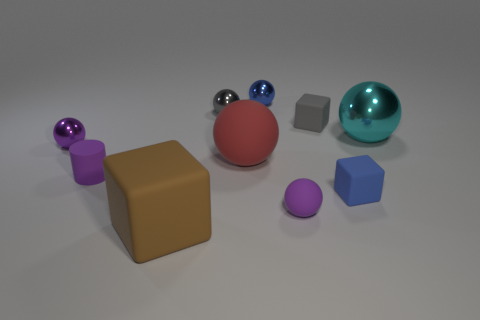Can you tell me about the lighting of this scene? The lighting of the scene is soft and diffused, coming from above as indicated by the soft shadows beneath the objects. The lack of harsh shadows suggests an indirect light source, creating a calm and evenly lit environment that minimizes contrast and allows the true colors of the objects to be visible.  How does the surface texture affect the perception of these objects? The glossy objects reflect light strongly, making them seem more vibrant and drawing attention to their form. In contrast, the matte objects absorb more light, which softens their appearance and makes their colors look more uniform. This interplay of textures adds visual interest to the scene and highlights the shapes and colors of the various objects. 